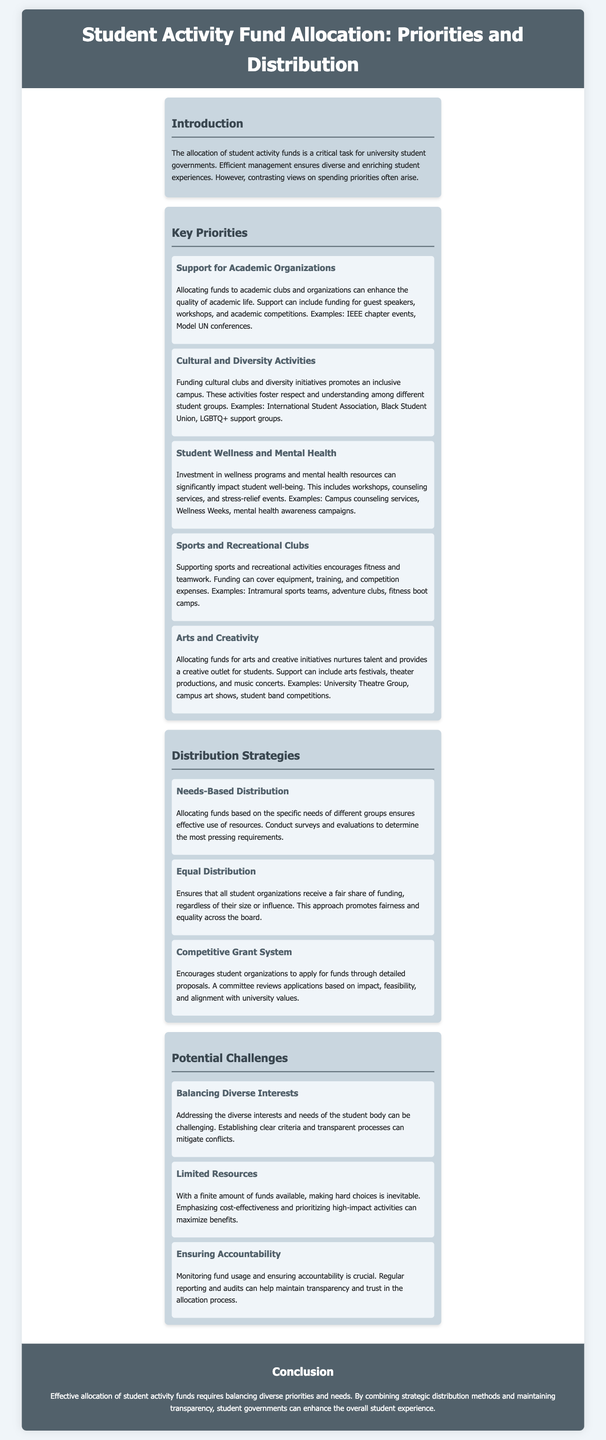What is the main topic of the document? The main topic of the document is about the allocation of funds for student activities within a university setting.
Answer: Student Activity Fund Allocation What are two examples of academic organizations mentioned? The document lists specific examples of academic organizations that receive funding, such as IEEE chapter events and Model UN conferences.
Answer: IEEE chapter events, Model UN conferences What is one priority related to student wellness? The document details that funds can be allocated towards wellness programs and mental health resources, specifically mentioning workshops and counseling services.
Answer: Workshops, counseling services How many distribution strategies are mentioned in the document? The document outlines three distinct distribution strategies for funds allocation.
Answer: Three Which distribution strategy promotes fairness among organizations? The document states that equal distribution ensures all student organizations receive a fair share of funding regardless of their size.
Answer: Equal Distribution What challenge is associated with limited funding? The document highlights that with a finite amount of funds, making difficult choices is a significant challenge in fund allocation.
Answer: Making hard choices What method can be used to ensure accountability in fund usage? Regular reporting and audits are methods mentioned in the document to maintain transparency and trust in fund allocation processes.
Answer: Reporting and audits Which section focuses on promoting cultural understanding? The section that addresses funding for promoting inclusivity among different student groups highlights cultural clubs and diversity initiatives.
Answer: Cultural and Diversity Activities 